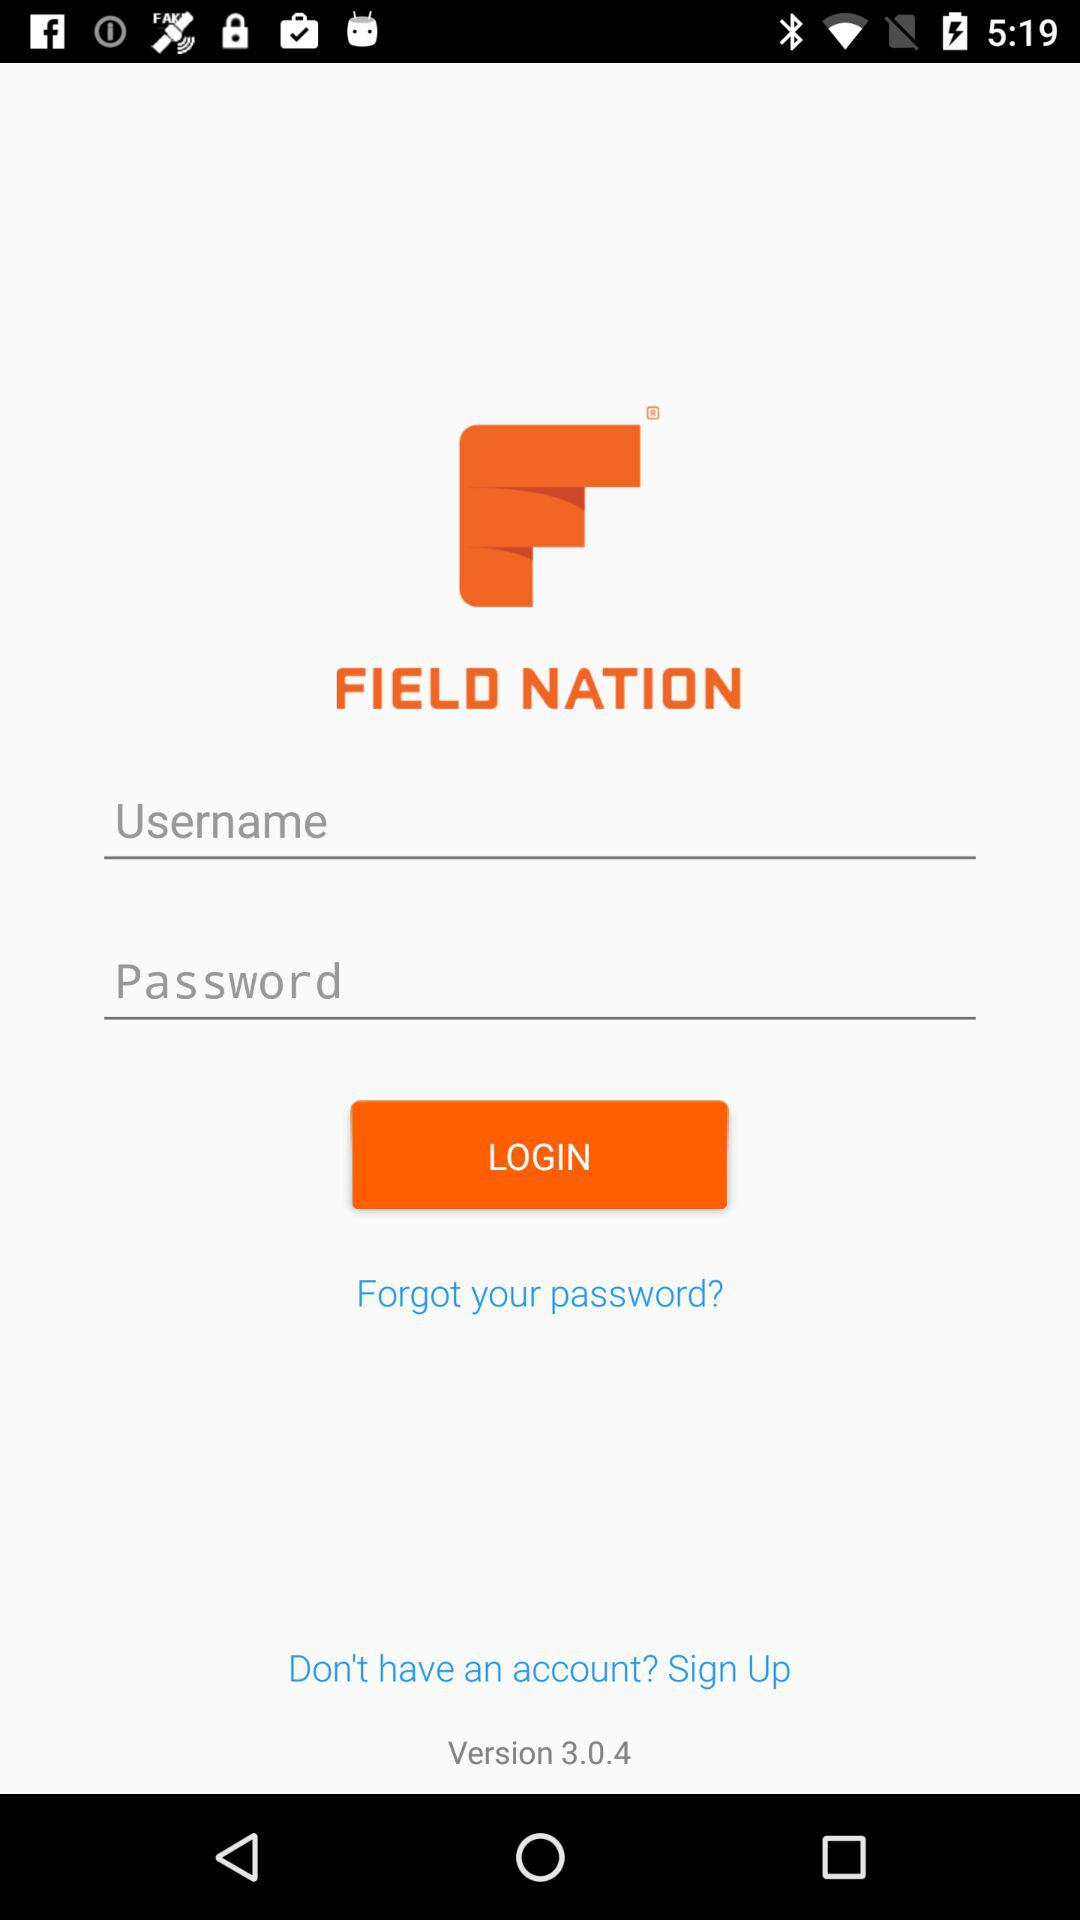What is the version? The version is 3.0.4. 